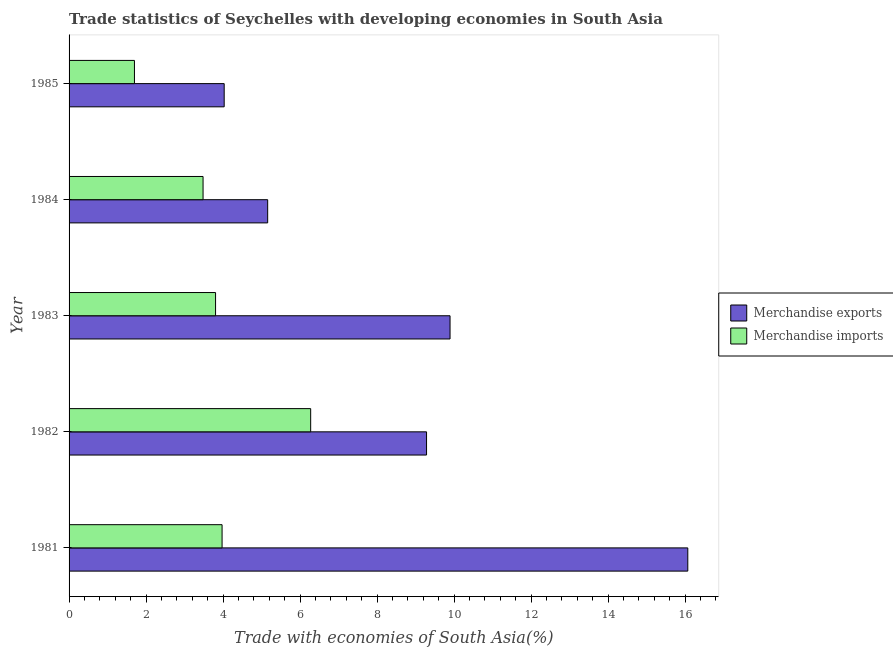Are the number of bars per tick equal to the number of legend labels?
Your answer should be very brief. Yes. What is the merchandise imports in 1983?
Ensure brevity in your answer.  3.8. Across all years, what is the maximum merchandise exports?
Ensure brevity in your answer.  16.07. Across all years, what is the minimum merchandise exports?
Make the answer very short. 4.03. What is the total merchandise imports in the graph?
Ensure brevity in your answer.  19.23. What is the difference between the merchandise imports in 1982 and that in 1983?
Make the answer very short. 2.47. What is the difference between the merchandise exports in 1981 and the merchandise imports in 1984?
Ensure brevity in your answer.  12.59. What is the average merchandise exports per year?
Ensure brevity in your answer.  8.89. In the year 1984, what is the difference between the merchandise imports and merchandise exports?
Your answer should be compact. -1.68. In how many years, is the merchandise imports greater than 7.2 %?
Provide a short and direct response. 0. What is the ratio of the merchandise exports in 1981 to that in 1985?
Provide a succinct answer. 3.99. What is the difference between the highest and the second highest merchandise imports?
Provide a short and direct response. 2.3. What is the difference between the highest and the lowest merchandise imports?
Offer a very short reply. 4.58. In how many years, is the merchandise imports greater than the average merchandise imports taken over all years?
Provide a short and direct response. 2. What does the 2nd bar from the top in 1985 represents?
Ensure brevity in your answer.  Merchandise exports. How many years are there in the graph?
Your response must be concise. 5. What is the difference between two consecutive major ticks on the X-axis?
Your answer should be compact. 2. Are the values on the major ticks of X-axis written in scientific E-notation?
Offer a terse response. No. Does the graph contain any zero values?
Your response must be concise. No. What is the title of the graph?
Provide a succinct answer. Trade statistics of Seychelles with developing economies in South Asia. Does "Highest 20% of population" appear as one of the legend labels in the graph?
Offer a terse response. No. What is the label or title of the X-axis?
Ensure brevity in your answer.  Trade with economies of South Asia(%). What is the label or title of the Y-axis?
Provide a succinct answer. Year. What is the Trade with economies of South Asia(%) of Merchandise exports in 1981?
Give a very brief answer. 16.07. What is the Trade with economies of South Asia(%) of Merchandise imports in 1981?
Provide a short and direct response. 3.97. What is the Trade with economies of South Asia(%) in Merchandise exports in 1982?
Provide a succinct answer. 9.29. What is the Trade with economies of South Asia(%) in Merchandise imports in 1982?
Ensure brevity in your answer.  6.28. What is the Trade with economies of South Asia(%) in Merchandise exports in 1983?
Offer a terse response. 9.9. What is the Trade with economies of South Asia(%) in Merchandise imports in 1983?
Offer a very short reply. 3.8. What is the Trade with economies of South Asia(%) in Merchandise exports in 1984?
Your answer should be compact. 5.16. What is the Trade with economies of South Asia(%) of Merchandise imports in 1984?
Offer a terse response. 3.48. What is the Trade with economies of South Asia(%) of Merchandise exports in 1985?
Offer a very short reply. 4.03. What is the Trade with economies of South Asia(%) of Merchandise imports in 1985?
Ensure brevity in your answer.  1.7. Across all years, what is the maximum Trade with economies of South Asia(%) of Merchandise exports?
Give a very brief answer. 16.07. Across all years, what is the maximum Trade with economies of South Asia(%) of Merchandise imports?
Make the answer very short. 6.28. Across all years, what is the minimum Trade with economies of South Asia(%) in Merchandise exports?
Your answer should be compact. 4.03. Across all years, what is the minimum Trade with economies of South Asia(%) in Merchandise imports?
Offer a very short reply. 1.7. What is the total Trade with economies of South Asia(%) of Merchandise exports in the graph?
Your answer should be very brief. 44.44. What is the total Trade with economies of South Asia(%) of Merchandise imports in the graph?
Your response must be concise. 19.23. What is the difference between the Trade with economies of South Asia(%) in Merchandise exports in 1981 and that in 1982?
Make the answer very short. 6.79. What is the difference between the Trade with economies of South Asia(%) of Merchandise imports in 1981 and that in 1982?
Give a very brief answer. -2.3. What is the difference between the Trade with economies of South Asia(%) in Merchandise exports in 1981 and that in 1983?
Your response must be concise. 6.18. What is the difference between the Trade with economies of South Asia(%) in Merchandise imports in 1981 and that in 1983?
Offer a terse response. 0.17. What is the difference between the Trade with economies of South Asia(%) in Merchandise exports in 1981 and that in 1984?
Your answer should be compact. 10.91. What is the difference between the Trade with economies of South Asia(%) of Merchandise imports in 1981 and that in 1984?
Ensure brevity in your answer.  0.49. What is the difference between the Trade with economies of South Asia(%) in Merchandise exports in 1981 and that in 1985?
Ensure brevity in your answer.  12.04. What is the difference between the Trade with economies of South Asia(%) in Merchandise imports in 1981 and that in 1985?
Offer a terse response. 2.28. What is the difference between the Trade with economies of South Asia(%) in Merchandise exports in 1982 and that in 1983?
Keep it short and to the point. -0.61. What is the difference between the Trade with economies of South Asia(%) in Merchandise imports in 1982 and that in 1983?
Your answer should be compact. 2.47. What is the difference between the Trade with economies of South Asia(%) of Merchandise exports in 1982 and that in 1984?
Provide a short and direct response. 4.13. What is the difference between the Trade with economies of South Asia(%) in Merchandise imports in 1982 and that in 1984?
Offer a terse response. 2.8. What is the difference between the Trade with economies of South Asia(%) of Merchandise exports in 1982 and that in 1985?
Your answer should be compact. 5.26. What is the difference between the Trade with economies of South Asia(%) of Merchandise imports in 1982 and that in 1985?
Make the answer very short. 4.58. What is the difference between the Trade with economies of South Asia(%) in Merchandise exports in 1983 and that in 1984?
Provide a short and direct response. 4.74. What is the difference between the Trade with economies of South Asia(%) of Merchandise imports in 1983 and that in 1984?
Your answer should be very brief. 0.32. What is the difference between the Trade with economies of South Asia(%) of Merchandise exports in 1983 and that in 1985?
Ensure brevity in your answer.  5.87. What is the difference between the Trade with economies of South Asia(%) of Merchandise imports in 1983 and that in 1985?
Ensure brevity in your answer.  2.11. What is the difference between the Trade with economies of South Asia(%) of Merchandise exports in 1984 and that in 1985?
Provide a short and direct response. 1.13. What is the difference between the Trade with economies of South Asia(%) in Merchandise imports in 1984 and that in 1985?
Offer a very short reply. 1.78. What is the difference between the Trade with economies of South Asia(%) in Merchandise exports in 1981 and the Trade with economies of South Asia(%) in Merchandise imports in 1982?
Provide a succinct answer. 9.8. What is the difference between the Trade with economies of South Asia(%) of Merchandise exports in 1981 and the Trade with economies of South Asia(%) of Merchandise imports in 1983?
Provide a short and direct response. 12.27. What is the difference between the Trade with economies of South Asia(%) of Merchandise exports in 1981 and the Trade with economies of South Asia(%) of Merchandise imports in 1984?
Your response must be concise. 12.59. What is the difference between the Trade with economies of South Asia(%) of Merchandise exports in 1981 and the Trade with economies of South Asia(%) of Merchandise imports in 1985?
Your answer should be very brief. 14.37. What is the difference between the Trade with economies of South Asia(%) of Merchandise exports in 1982 and the Trade with economies of South Asia(%) of Merchandise imports in 1983?
Give a very brief answer. 5.48. What is the difference between the Trade with economies of South Asia(%) in Merchandise exports in 1982 and the Trade with economies of South Asia(%) in Merchandise imports in 1984?
Give a very brief answer. 5.81. What is the difference between the Trade with economies of South Asia(%) of Merchandise exports in 1982 and the Trade with economies of South Asia(%) of Merchandise imports in 1985?
Make the answer very short. 7.59. What is the difference between the Trade with economies of South Asia(%) of Merchandise exports in 1983 and the Trade with economies of South Asia(%) of Merchandise imports in 1984?
Ensure brevity in your answer.  6.42. What is the difference between the Trade with economies of South Asia(%) in Merchandise exports in 1983 and the Trade with economies of South Asia(%) in Merchandise imports in 1985?
Ensure brevity in your answer.  8.2. What is the difference between the Trade with economies of South Asia(%) in Merchandise exports in 1984 and the Trade with economies of South Asia(%) in Merchandise imports in 1985?
Provide a succinct answer. 3.46. What is the average Trade with economies of South Asia(%) in Merchandise exports per year?
Ensure brevity in your answer.  8.89. What is the average Trade with economies of South Asia(%) in Merchandise imports per year?
Your answer should be compact. 3.85. In the year 1981, what is the difference between the Trade with economies of South Asia(%) of Merchandise exports and Trade with economies of South Asia(%) of Merchandise imports?
Provide a short and direct response. 12.1. In the year 1982, what is the difference between the Trade with economies of South Asia(%) in Merchandise exports and Trade with economies of South Asia(%) in Merchandise imports?
Your answer should be very brief. 3.01. In the year 1983, what is the difference between the Trade with economies of South Asia(%) in Merchandise exports and Trade with economies of South Asia(%) in Merchandise imports?
Provide a short and direct response. 6.09. In the year 1984, what is the difference between the Trade with economies of South Asia(%) of Merchandise exports and Trade with economies of South Asia(%) of Merchandise imports?
Provide a short and direct response. 1.68. In the year 1985, what is the difference between the Trade with economies of South Asia(%) in Merchandise exports and Trade with economies of South Asia(%) in Merchandise imports?
Ensure brevity in your answer.  2.33. What is the ratio of the Trade with economies of South Asia(%) in Merchandise exports in 1981 to that in 1982?
Offer a very short reply. 1.73. What is the ratio of the Trade with economies of South Asia(%) of Merchandise imports in 1981 to that in 1982?
Offer a very short reply. 0.63. What is the ratio of the Trade with economies of South Asia(%) in Merchandise exports in 1981 to that in 1983?
Provide a succinct answer. 1.62. What is the ratio of the Trade with economies of South Asia(%) in Merchandise imports in 1981 to that in 1983?
Your answer should be compact. 1.04. What is the ratio of the Trade with economies of South Asia(%) in Merchandise exports in 1981 to that in 1984?
Ensure brevity in your answer.  3.12. What is the ratio of the Trade with economies of South Asia(%) of Merchandise imports in 1981 to that in 1984?
Keep it short and to the point. 1.14. What is the ratio of the Trade with economies of South Asia(%) in Merchandise exports in 1981 to that in 1985?
Your response must be concise. 3.99. What is the ratio of the Trade with economies of South Asia(%) in Merchandise imports in 1981 to that in 1985?
Provide a succinct answer. 2.34. What is the ratio of the Trade with economies of South Asia(%) of Merchandise exports in 1982 to that in 1983?
Offer a terse response. 0.94. What is the ratio of the Trade with economies of South Asia(%) of Merchandise imports in 1982 to that in 1983?
Ensure brevity in your answer.  1.65. What is the ratio of the Trade with economies of South Asia(%) in Merchandise imports in 1982 to that in 1984?
Provide a short and direct response. 1.8. What is the ratio of the Trade with economies of South Asia(%) in Merchandise exports in 1982 to that in 1985?
Keep it short and to the point. 2.3. What is the ratio of the Trade with economies of South Asia(%) in Merchandise imports in 1982 to that in 1985?
Ensure brevity in your answer.  3.69. What is the ratio of the Trade with economies of South Asia(%) of Merchandise exports in 1983 to that in 1984?
Give a very brief answer. 1.92. What is the ratio of the Trade with economies of South Asia(%) in Merchandise imports in 1983 to that in 1984?
Give a very brief answer. 1.09. What is the ratio of the Trade with economies of South Asia(%) of Merchandise exports in 1983 to that in 1985?
Your answer should be very brief. 2.46. What is the ratio of the Trade with economies of South Asia(%) in Merchandise imports in 1983 to that in 1985?
Ensure brevity in your answer.  2.24. What is the ratio of the Trade with economies of South Asia(%) in Merchandise exports in 1984 to that in 1985?
Your answer should be compact. 1.28. What is the ratio of the Trade with economies of South Asia(%) of Merchandise imports in 1984 to that in 1985?
Make the answer very short. 2.05. What is the difference between the highest and the second highest Trade with economies of South Asia(%) of Merchandise exports?
Ensure brevity in your answer.  6.18. What is the difference between the highest and the second highest Trade with economies of South Asia(%) of Merchandise imports?
Your answer should be compact. 2.3. What is the difference between the highest and the lowest Trade with economies of South Asia(%) of Merchandise exports?
Your answer should be very brief. 12.04. What is the difference between the highest and the lowest Trade with economies of South Asia(%) in Merchandise imports?
Offer a very short reply. 4.58. 